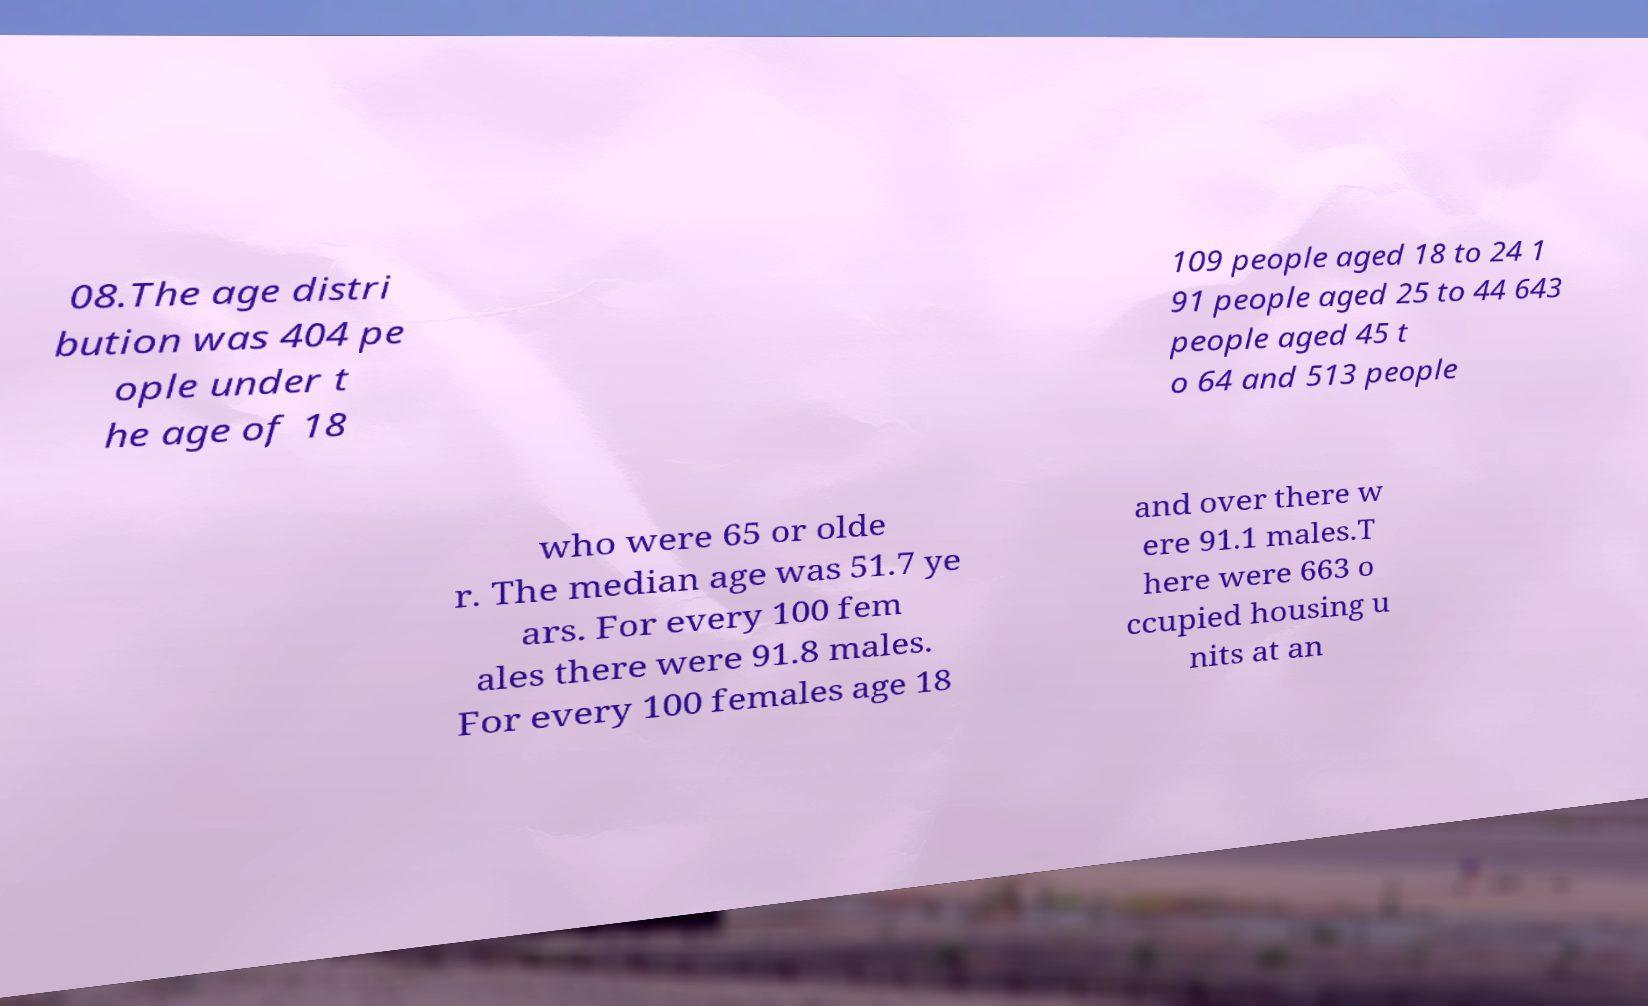Please identify and transcribe the text found in this image. 08.The age distri bution was 404 pe ople under t he age of 18 109 people aged 18 to 24 1 91 people aged 25 to 44 643 people aged 45 t o 64 and 513 people who were 65 or olde r. The median age was 51.7 ye ars. For every 100 fem ales there were 91.8 males. For every 100 females age 18 and over there w ere 91.1 males.T here were 663 o ccupied housing u nits at an 